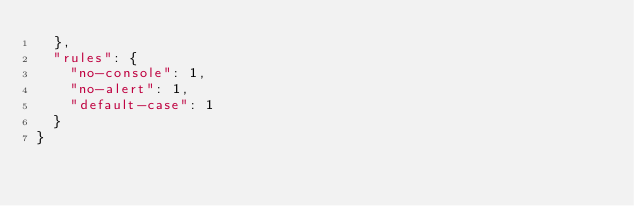Convert code to text. <code><loc_0><loc_0><loc_500><loc_500><_JavaScript_>  },
  "rules": {
    "no-console": 1,
    "no-alert": 1,
    "default-case": 1
  }
}
</code> 